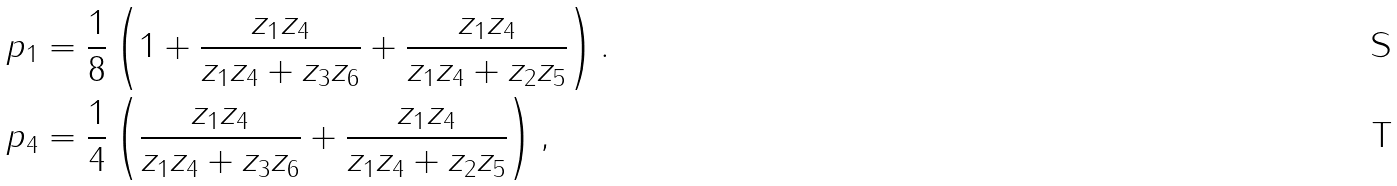<formula> <loc_0><loc_0><loc_500><loc_500>p _ { 1 } & = \frac { 1 } { 8 } \left ( 1 + \frac { z _ { 1 } z _ { 4 } } { z _ { 1 } z _ { 4 } + z _ { 3 } z _ { 6 } } + \frac { z _ { 1 } z _ { 4 } } { z _ { 1 } z _ { 4 } + z _ { 2 } z _ { 5 } } \right ) . \\ p _ { 4 } & = \frac { 1 } { 4 } \left ( \frac { z _ { 1 } z _ { 4 } } { z _ { 1 } z _ { 4 } + z _ { 3 } z _ { 6 } } + \frac { z _ { 1 } z _ { 4 } } { z _ { 1 } z _ { 4 } + z _ { 2 } z _ { 5 } } \right ) ,</formula> 